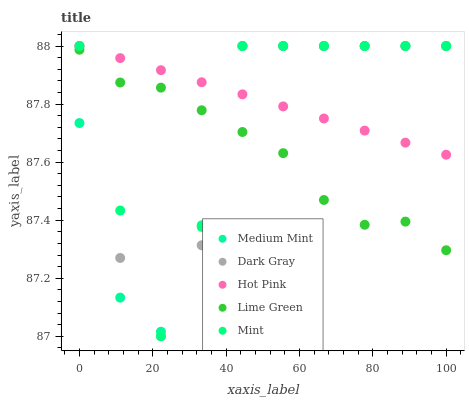Does Lime Green have the minimum area under the curve?
Answer yes or no. Yes. Does Hot Pink have the maximum area under the curve?
Answer yes or no. Yes. Does Dark Gray have the minimum area under the curve?
Answer yes or no. No. Does Dark Gray have the maximum area under the curve?
Answer yes or no. No. Is Hot Pink the smoothest?
Answer yes or no. Yes. Is Dark Gray the roughest?
Answer yes or no. Yes. Is Dark Gray the smoothest?
Answer yes or no. No. Is Hot Pink the roughest?
Answer yes or no. No. Does Dark Gray have the lowest value?
Answer yes or no. Yes. Does Hot Pink have the lowest value?
Answer yes or no. No. Does Mint have the highest value?
Answer yes or no. Yes. Does Lime Green have the highest value?
Answer yes or no. No. Is Lime Green less than Hot Pink?
Answer yes or no. Yes. Is Hot Pink greater than Lime Green?
Answer yes or no. Yes. Does Lime Green intersect Dark Gray?
Answer yes or no. Yes. Is Lime Green less than Dark Gray?
Answer yes or no. No. Is Lime Green greater than Dark Gray?
Answer yes or no. No. Does Lime Green intersect Hot Pink?
Answer yes or no. No. 